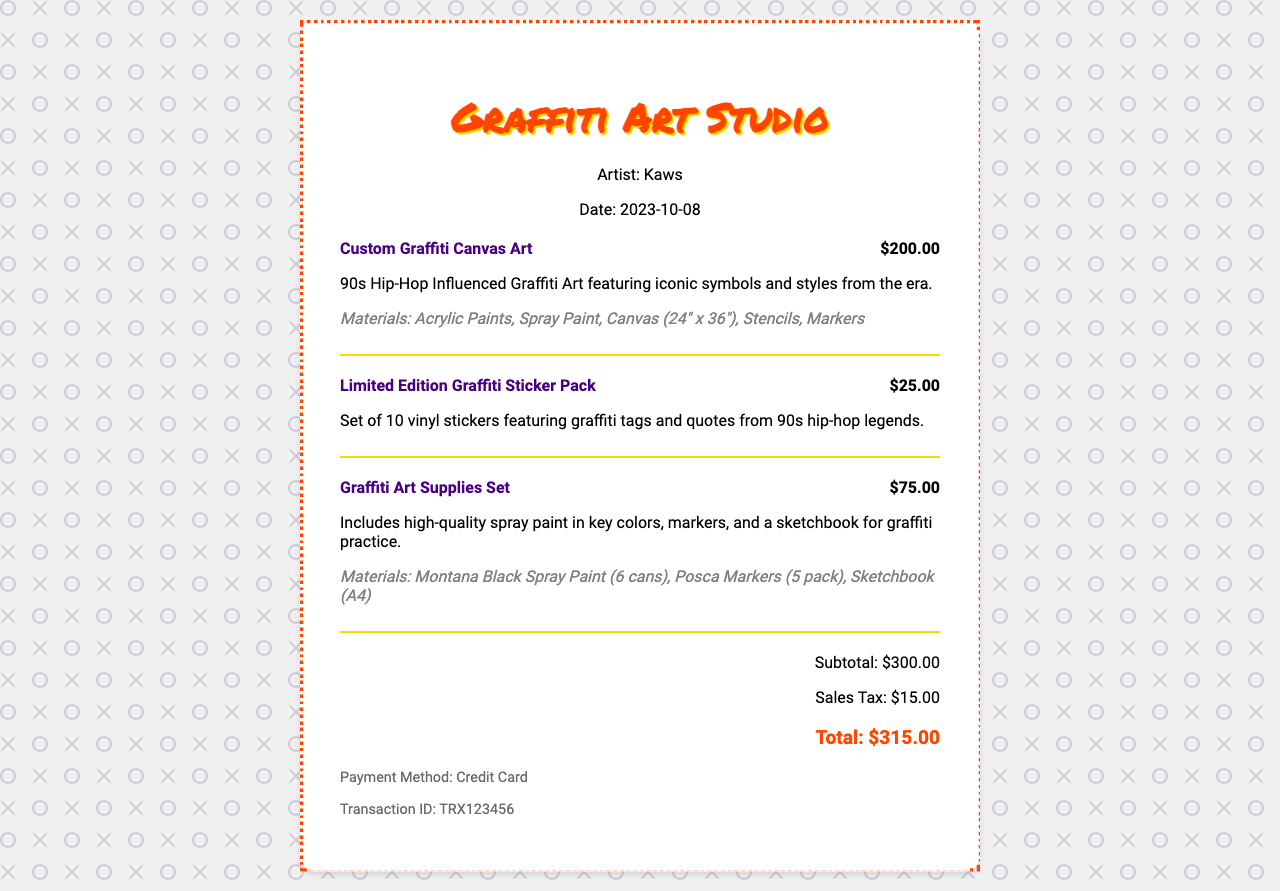what is the artist's name? The artist's name is specified in the merchant info section of the receipt.
Answer: Kaws when was the purchase made? The date of purchase is indicated in the merchant info section of the receipt.
Answer: 2023-10-08 how much does the custom graffiti canvas art cost? The price for the custom graffiti canvas art is stated next to the item's title.
Answer: $200.00 what is the subtotal amount before tax? The subtotal is listed separately in the totals section of the receipt.
Answer: $300.00 how many items are included in the limited edition graffiti sticker pack? The number of items in the sticker pack is detailed in the item's description.
Answer: 10 what materials were used for the custom graffiti canvas art? The materials for the custom graffiti canvas art are mentioned in the item's description.
Answer: Acrylic Paints, Spray Paint, Canvas (24" x 36"), Stencils, Markers what is the total amount after tax? The total amount is provided in the totals section of the receipt.
Answer: $315.00 how much was charged for sales tax? The sales tax amount is specified in the totals section of the receipt.
Answer: $15.00 what payment method was used? The payment method is indicated in the payment info section of the receipt.
Answer: Credit Card 